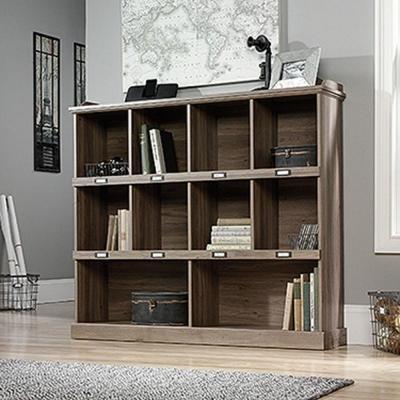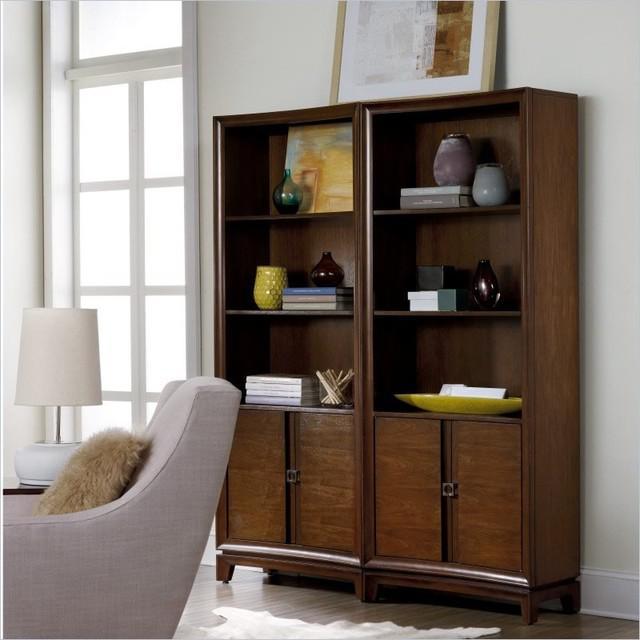The first image is the image on the left, the second image is the image on the right. For the images displayed, is the sentence "One large shelf unit is shown with an optional ladder accessory." factually correct? Answer yes or no. No. 